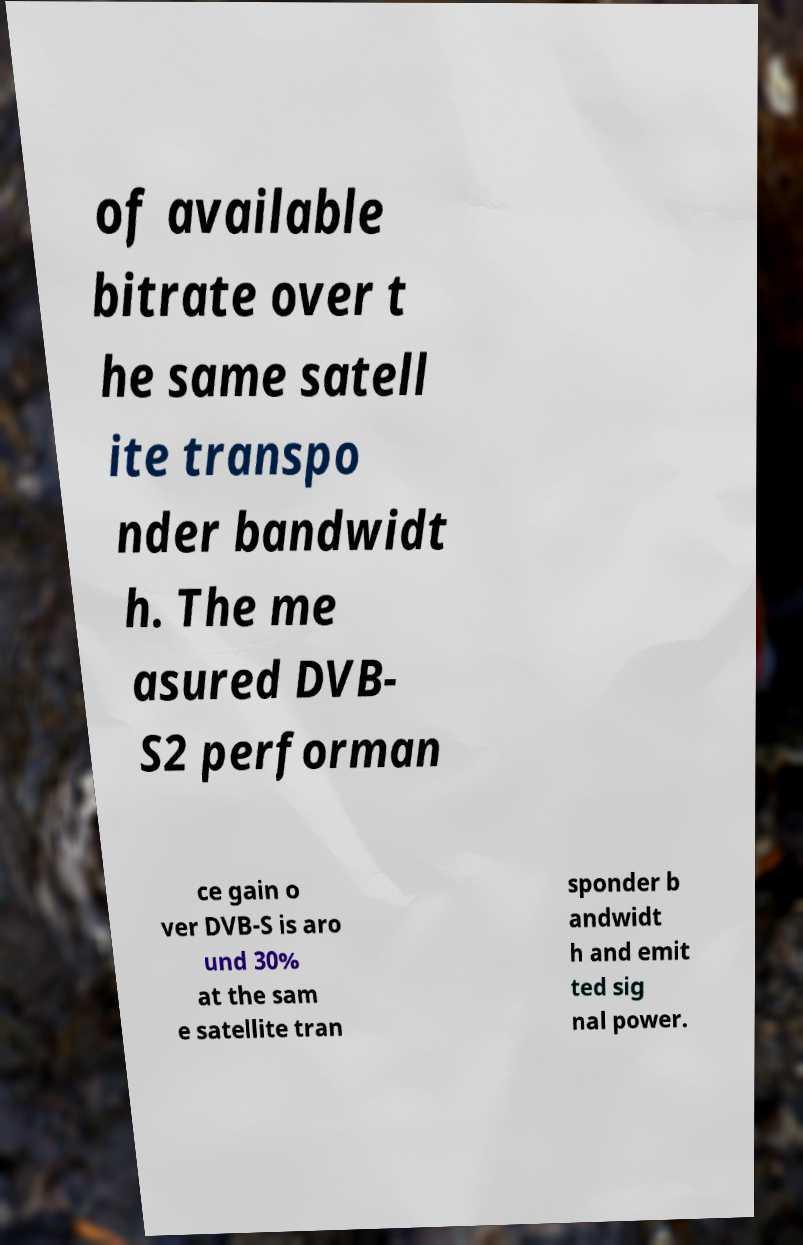Could you extract and type out the text from this image? of available bitrate over t he same satell ite transpo nder bandwidt h. The me asured DVB- S2 performan ce gain o ver DVB-S is aro und 30% at the sam e satellite tran sponder b andwidt h and emit ted sig nal power. 